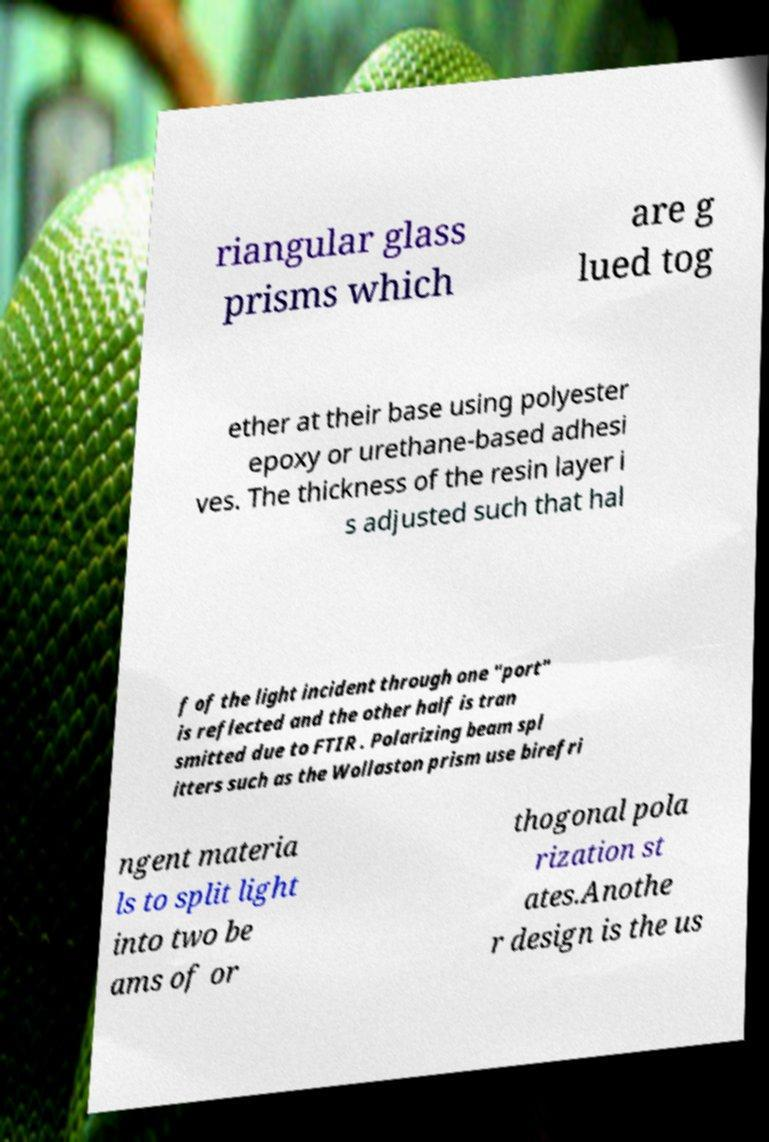Could you assist in decoding the text presented in this image and type it out clearly? riangular glass prisms which are g lued tog ether at their base using polyester epoxy or urethane-based adhesi ves. The thickness of the resin layer i s adjusted such that hal f of the light incident through one "port" is reflected and the other half is tran smitted due to FTIR . Polarizing beam spl itters such as the Wollaston prism use birefri ngent materia ls to split light into two be ams of or thogonal pola rization st ates.Anothe r design is the us 